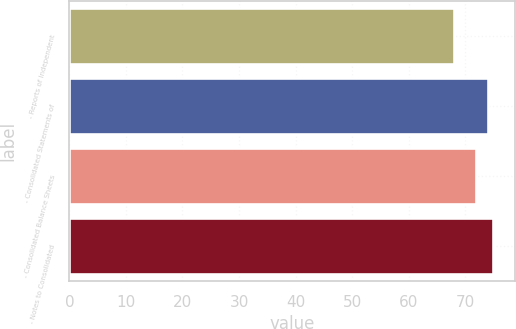Convert chart to OTSL. <chart><loc_0><loc_0><loc_500><loc_500><bar_chart><fcel>- Reports of Independent<fcel>- Consolidated Statements of<fcel>- Consolidated Balance Sheets<fcel>- Notes to Consolidated<nl><fcel>68<fcel>74<fcel>72<fcel>75<nl></chart> 